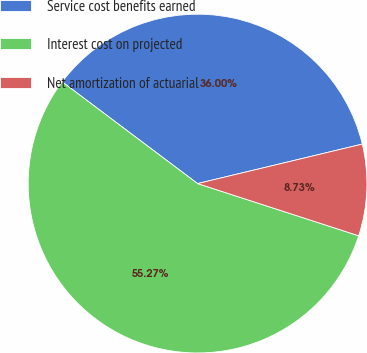Convert chart. <chart><loc_0><loc_0><loc_500><loc_500><pie_chart><fcel>Service cost benefits earned<fcel>Interest cost on projected<fcel>Net amortization of actuarial<nl><fcel>36.0%<fcel>55.27%<fcel>8.73%<nl></chart> 